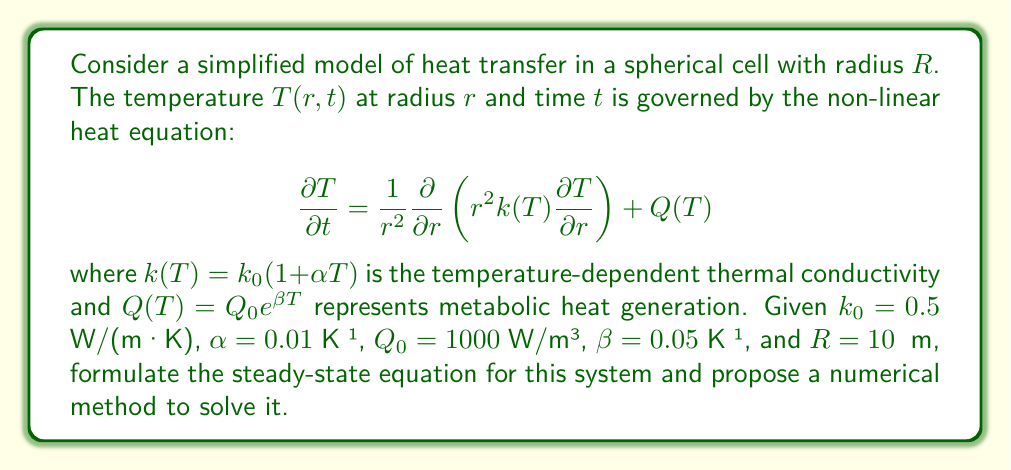Solve this math problem. Let's approach this step-by-step:

1) First, we need to formulate the steady-state equation. In steady-state, the temperature doesn't change with time, so $\frac{\partial T}{\partial t} = 0$. This gives us:

   $$0 = \frac{1}{r^2}\frac{\partial}{\partial r}\left(r^2k(T)\frac{\partial T}{\partial r}\right) + Q(T)$$

2) Expanding the derivative and substituting the expressions for $k(T)$ and $Q(T)$:

   $$0 = \frac{1}{r^2}\frac{\partial}{\partial r}\left(r^2k_0(1 + \alpha T)\frac{\partial T}{\partial r}\right) + Q_0e^{\beta T}$$

3) This is a non-linear second-order differential equation. Due to its non-linearity, it's challenging to solve analytically. A numerical method is more appropriate.

4) One suitable numerical method is the finite difference method with iteration. Here's how we can apply it:

   a) Discretize the radius into $N$ points: $r_i = i\Delta r$, where $\Delta r = R/N$ and $i = 0, 1, ..., N$.
   
   b) Approximate the derivatives using central differences:
   
      $$\frac{\partial T}{\partial r} \approx \frac{T_{i+1} - T_{i-1}}{2\Delta r}$$
      $$\frac{\partial^2 T}{\partial r^2} \approx \frac{T_{i+1} - 2T_i + T_{i-1}}{(\Delta r)^2}$$

   c) Substitute these into the steady-state equation and rearrange to get an iteration formula for $T_i$:

      $$T_i^{new} = f(T_{i-1}, T_i, T_{i+1})$$

   d) Start with an initial guess for $T_i$ at all points.
   
   e) Iterate the formula until the change in temperature between iterations is below a certain threshold.

5) Boundary conditions are needed to complete the problem:
   - At $r = 0$ (center): $\frac{\partial T}{\partial r} = 0$ (symmetry condition)
   - At $r = R$ (surface): Either specify $T$ or $\frac{\partial T}{\partial r}$ based on the external conditions

6) The iteration process will converge to the steady-state temperature profile, giving us the solution to the non-linear heat equation in this biological system.
Answer: Steady-state equation: $0 = \frac{1}{r^2}\frac{\partial}{\partial r}\left(r^2k_0(1 + \alpha T)\frac{\partial T}{\partial r}\right) + Q_0e^{\beta T}$. Solve using finite difference method with iteration. 